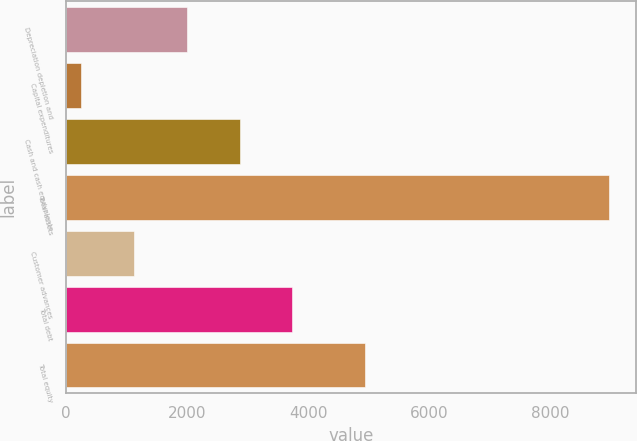<chart> <loc_0><loc_0><loc_500><loc_500><bar_chart><fcel>Depreciation depletion and<fcel>Capital expenditures<fcel>Cash and cash equivalents<fcel>Total assets<fcel>Customer advances<fcel>Total debt<fcel>Total equity<nl><fcel>1992.66<fcel>247.2<fcel>2865.39<fcel>8974.5<fcel>1119.93<fcel>3738.12<fcel>4932.9<nl></chart> 